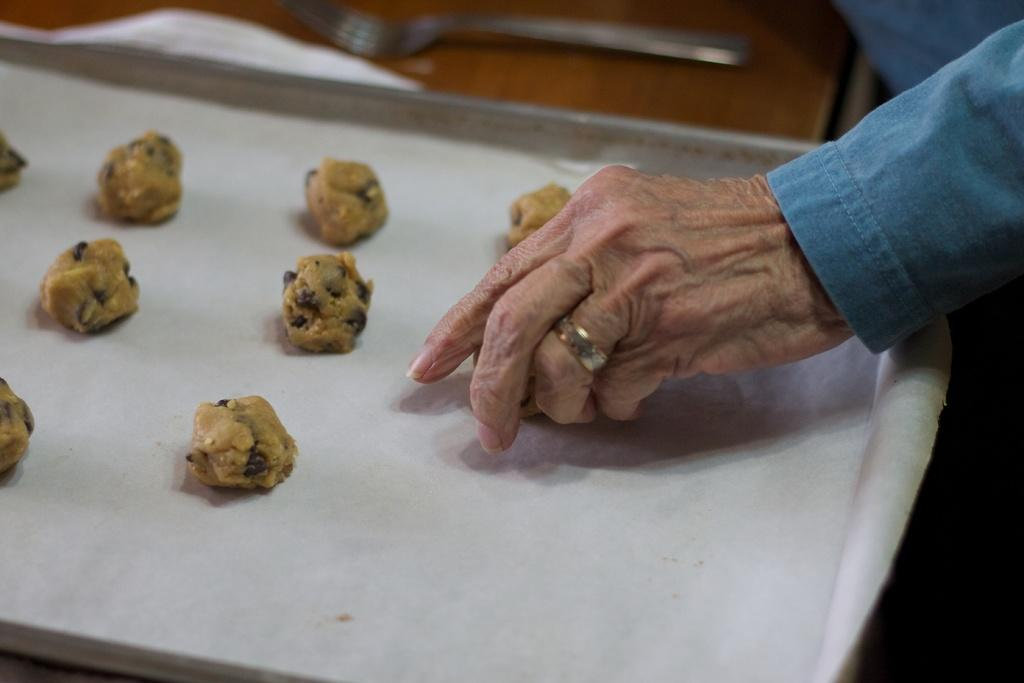What is present on the tray in the image? There is cookie dough in the image. What is used to cover the cookie dough on the tray? There is a butter paper in the image. What utensil is visible in the image? There is a fork in the image. What type of table is the tray placed on? There is a wooden table in the image. Whose hand can be seen in the image? A person's hand is visible in the image. What decision does the deer make in the image? There is no deer present in the image, so it is not possible to answer that question. 